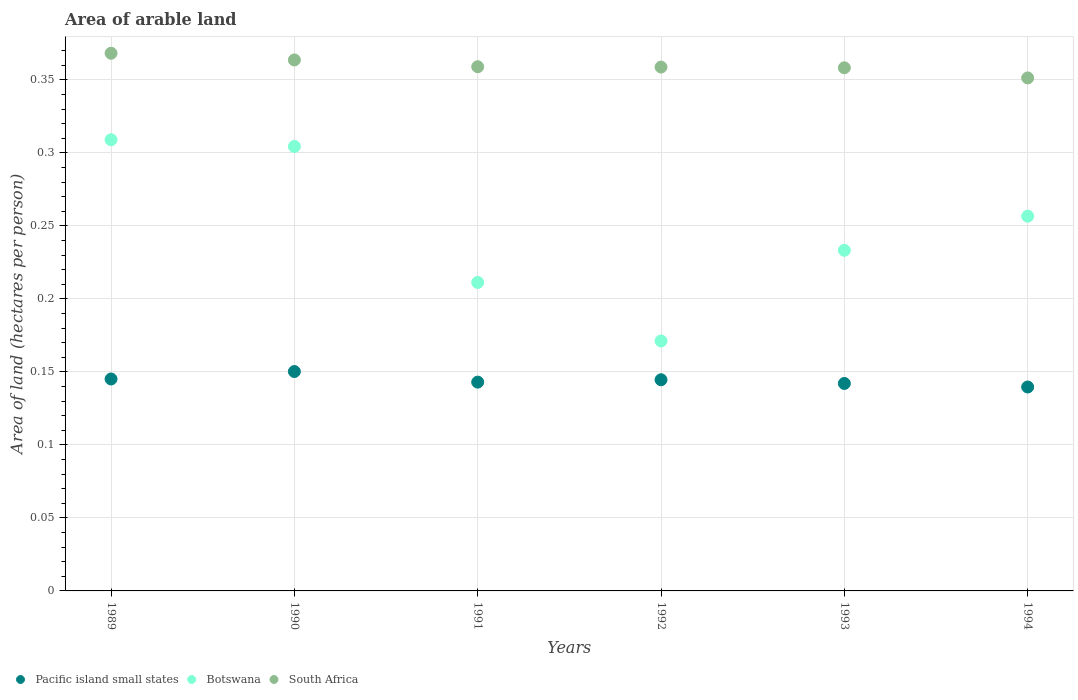What is the total arable land in South Africa in 1991?
Your response must be concise. 0.36. Across all years, what is the maximum total arable land in South Africa?
Keep it short and to the point. 0.37. Across all years, what is the minimum total arable land in Pacific island small states?
Make the answer very short. 0.14. In which year was the total arable land in Pacific island small states minimum?
Give a very brief answer. 1994. What is the total total arable land in Pacific island small states in the graph?
Offer a terse response. 0.86. What is the difference between the total arable land in South Africa in 1989 and that in 1990?
Make the answer very short. 0. What is the difference between the total arable land in Pacific island small states in 1993 and the total arable land in Botswana in 1991?
Ensure brevity in your answer.  -0.07. What is the average total arable land in Pacific island small states per year?
Offer a very short reply. 0.14. In the year 1991, what is the difference between the total arable land in South Africa and total arable land in Pacific island small states?
Your answer should be compact. 0.22. In how many years, is the total arable land in Botswana greater than 0.12000000000000001 hectares per person?
Your answer should be very brief. 6. What is the ratio of the total arable land in South Africa in 1992 to that in 1994?
Provide a short and direct response. 1.02. Is the total arable land in Botswana in 1992 less than that in 1994?
Give a very brief answer. Yes. What is the difference between the highest and the second highest total arable land in South Africa?
Ensure brevity in your answer.  0. What is the difference between the highest and the lowest total arable land in Botswana?
Keep it short and to the point. 0.14. In how many years, is the total arable land in Pacific island small states greater than the average total arable land in Pacific island small states taken over all years?
Ensure brevity in your answer.  3. Is the sum of the total arable land in Pacific island small states in 1991 and 1992 greater than the maximum total arable land in Botswana across all years?
Provide a short and direct response. No. Is it the case that in every year, the sum of the total arable land in South Africa and total arable land in Botswana  is greater than the total arable land in Pacific island small states?
Your response must be concise. Yes. Does the total arable land in South Africa monotonically increase over the years?
Give a very brief answer. No. Is the total arable land in South Africa strictly greater than the total arable land in Botswana over the years?
Offer a terse response. Yes. How many dotlines are there?
Your answer should be compact. 3. What is the difference between two consecutive major ticks on the Y-axis?
Ensure brevity in your answer.  0.05. Are the values on the major ticks of Y-axis written in scientific E-notation?
Offer a terse response. No. Does the graph contain grids?
Provide a short and direct response. Yes. Where does the legend appear in the graph?
Keep it short and to the point. Bottom left. What is the title of the graph?
Give a very brief answer. Area of arable land. Does "New Caledonia" appear as one of the legend labels in the graph?
Your answer should be very brief. No. What is the label or title of the X-axis?
Offer a terse response. Years. What is the label or title of the Y-axis?
Make the answer very short. Area of land (hectares per person). What is the Area of land (hectares per person) of Pacific island small states in 1989?
Offer a terse response. 0.15. What is the Area of land (hectares per person) of Botswana in 1989?
Give a very brief answer. 0.31. What is the Area of land (hectares per person) in South Africa in 1989?
Keep it short and to the point. 0.37. What is the Area of land (hectares per person) in Pacific island small states in 1990?
Provide a short and direct response. 0.15. What is the Area of land (hectares per person) of Botswana in 1990?
Your answer should be very brief. 0.3. What is the Area of land (hectares per person) of South Africa in 1990?
Provide a succinct answer. 0.36. What is the Area of land (hectares per person) in Pacific island small states in 1991?
Offer a very short reply. 0.14. What is the Area of land (hectares per person) in Botswana in 1991?
Keep it short and to the point. 0.21. What is the Area of land (hectares per person) of South Africa in 1991?
Your answer should be very brief. 0.36. What is the Area of land (hectares per person) of Pacific island small states in 1992?
Offer a very short reply. 0.14. What is the Area of land (hectares per person) in Botswana in 1992?
Provide a short and direct response. 0.17. What is the Area of land (hectares per person) of South Africa in 1992?
Make the answer very short. 0.36. What is the Area of land (hectares per person) of Pacific island small states in 1993?
Provide a succinct answer. 0.14. What is the Area of land (hectares per person) of Botswana in 1993?
Provide a short and direct response. 0.23. What is the Area of land (hectares per person) of South Africa in 1993?
Offer a very short reply. 0.36. What is the Area of land (hectares per person) of Pacific island small states in 1994?
Give a very brief answer. 0.14. What is the Area of land (hectares per person) of Botswana in 1994?
Your response must be concise. 0.26. What is the Area of land (hectares per person) in South Africa in 1994?
Keep it short and to the point. 0.35. Across all years, what is the maximum Area of land (hectares per person) in Pacific island small states?
Ensure brevity in your answer.  0.15. Across all years, what is the maximum Area of land (hectares per person) of Botswana?
Your response must be concise. 0.31. Across all years, what is the maximum Area of land (hectares per person) in South Africa?
Offer a terse response. 0.37. Across all years, what is the minimum Area of land (hectares per person) of Pacific island small states?
Ensure brevity in your answer.  0.14. Across all years, what is the minimum Area of land (hectares per person) of Botswana?
Your answer should be very brief. 0.17. Across all years, what is the minimum Area of land (hectares per person) in South Africa?
Make the answer very short. 0.35. What is the total Area of land (hectares per person) of Pacific island small states in the graph?
Provide a succinct answer. 0.86. What is the total Area of land (hectares per person) in Botswana in the graph?
Offer a very short reply. 1.49. What is the total Area of land (hectares per person) of South Africa in the graph?
Keep it short and to the point. 2.16. What is the difference between the Area of land (hectares per person) of Pacific island small states in 1989 and that in 1990?
Make the answer very short. -0.01. What is the difference between the Area of land (hectares per person) of Botswana in 1989 and that in 1990?
Offer a very short reply. 0. What is the difference between the Area of land (hectares per person) in South Africa in 1989 and that in 1990?
Provide a succinct answer. 0. What is the difference between the Area of land (hectares per person) of Pacific island small states in 1989 and that in 1991?
Offer a terse response. 0. What is the difference between the Area of land (hectares per person) of Botswana in 1989 and that in 1991?
Provide a succinct answer. 0.1. What is the difference between the Area of land (hectares per person) in South Africa in 1989 and that in 1991?
Provide a succinct answer. 0.01. What is the difference between the Area of land (hectares per person) of Pacific island small states in 1989 and that in 1992?
Your response must be concise. 0. What is the difference between the Area of land (hectares per person) in Botswana in 1989 and that in 1992?
Offer a terse response. 0.14. What is the difference between the Area of land (hectares per person) in South Africa in 1989 and that in 1992?
Ensure brevity in your answer.  0.01. What is the difference between the Area of land (hectares per person) of Pacific island small states in 1989 and that in 1993?
Offer a very short reply. 0. What is the difference between the Area of land (hectares per person) in Botswana in 1989 and that in 1993?
Give a very brief answer. 0.08. What is the difference between the Area of land (hectares per person) in South Africa in 1989 and that in 1993?
Keep it short and to the point. 0.01. What is the difference between the Area of land (hectares per person) of Pacific island small states in 1989 and that in 1994?
Provide a short and direct response. 0.01. What is the difference between the Area of land (hectares per person) in Botswana in 1989 and that in 1994?
Offer a terse response. 0.05. What is the difference between the Area of land (hectares per person) of South Africa in 1989 and that in 1994?
Offer a very short reply. 0.02. What is the difference between the Area of land (hectares per person) of Pacific island small states in 1990 and that in 1991?
Your answer should be compact. 0.01. What is the difference between the Area of land (hectares per person) in Botswana in 1990 and that in 1991?
Keep it short and to the point. 0.09. What is the difference between the Area of land (hectares per person) in South Africa in 1990 and that in 1991?
Your answer should be very brief. 0. What is the difference between the Area of land (hectares per person) of Pacific island small states in 1990 and that in 1992?
Your answer should be very brief. 0.01. What is the difference between the Area of land (hectares per person) of Botswana in 1990 and that in 1992?
Offer a terse response. 0.13. What is the difference between the Area of land (hectares per person) in South Africa in 1990 and that in 1992?
Give a very brief answer. 0. What is the difference between the Area of land (hectares per person) of Pacific island small states in 1990 and that in 1993?
Your answer should be very brief. 0.01. What is the difference between the Area of land (hectares per person) of Botswana in 1990 and that in 1993?
Your answer should be very brief. 0.07. What is the difference between the Area of land (hectares per person) in South Africa in 1990 and that in 1993?
Give a very brief answer. 0.01. What is the difference between the Area of land (hectares per person) in Pacific island small states in 1990 and that in 1994?
Provide a short and direct response. 0.01. What is the difference between the Area of land (hectares per person) in Botswana in 1990 and that in 1994?
Give a very brief answer. 0.05. What is the difference between the Area of land (hectares per person) in South Africa in 1990 and that in 1994?
Ensure brevity in your answer.  0.01. What is the difference between the Area of land (hectares per person) in Pacific island small states in 1991 and that in 1992?
Keep it short and to the point. -0. What is the difference between the Area of land (hectares per person) in Botswana in 1991 and that in 1992?
Make the answer very short. 0.04. What is the difference between the Area of land (hectares per person) of South Africa in 1991 and that in 1992?
Your answer should be very brief. 0. What is the difference between the Area of land (hectares per person) in Pacific island small states in 1991 and that in 1993?
Provide a short and direct response. 0. What is the difference between the Area of land (hectares per person) of Botswana in 1991 and that in 1993?
Provide a short and direct response. -0.02. What is the difference between the Area of land (hectares per person) of South Africa in 1991 and that in 1993?
Your response must be concise. 0. What is the difference between the Area of land (hectares per person) of Pacific island small states in 1991 and that in 1994?
Give a very brief answer. 0. What is the difference between the Area of land (hectares per person) of Botswana in 1991 and that in 1994?
Give a very brief answer. -0.05. What is the difference between the Area of land (hectares per person) of South Africa in 1991 and that in 1994?
Give a very brief answer. 0.01. What is the difference between the Area of land (hectares per person) in Pacific island small states in 1992 and that in 1993?
Your response must be concise. 0. What is the difference between the Area of land (hectares per person) of Botswana in 1992 and that in 1993?
Offer a very short reply. -0.06. What is the difference between the Area of land (hectares per person) in Pacific island small states in 1992 and that in 1994?
Provide a succinct answer. 0.01. What is the difference between the Area of land (hectares per person) in Botswana in 1992 and that in 1994?
Offer a very short reply. -0.09. What is the difference between the Area of land (hectares per person) of South Africa in 1992 and that in 1994?
Offer a terse response. 0.01. What is the difference between the Area of land (hectares per person) of Pacific island small states in 1993 and that in 1994?
Provide a short and direct response. 0. What is the difference between the Area of land (hectares per person) of Botswana in 1993 and that in 1994?
Your answer should be compact. -0.02. What is the difference between the Area of land (hectares per person) of South Africa in 1993 and that in 1994?
Make the answer very short. 0.01. What is the difference between the Area of land (hectares per person) of Pacific island small states in 1989 and the Area of land (hectares per person) of Botswana in 1990?
Give a very brief answer. -0.16. What is the difference between the Area of land (hectares per person) in Pacific island small states in 1989 and the Area of land (hectares per person) in South Africa in 1990?
Your answer should be very brief. -0.22. What is the difference between the Area of land (hectares per person) of Botswana in 1989 and the Area of land (hectares per person) of South Africa in 1990?
Offer a terse response. -0.05. What is the difference between the Area of land (hectares per person) in Pacific island small states in 1989 and the Area of land (hectares per person) in Botswana in 1991?
Give a very brief answer. -0.07. What is the difference between the Area of land (hectares per person) in Pacific island small states in 1989 and the Area of land (hectares per person) in South Africa in 1991?
Your answer should be very brief. -0.21. What is the difference between the Area of land (hectares per person) in Botswana in 1989 and the Area of land (hectares per person) in South Africa in 1991?
Offer a terse response. -0.05. What is the difference between the Area of land (hectares per person) in Pacific island small states in 1989 and the Area of land (hectares per person) in Botswana in 1992?
Ensure brevity in your answer.  -0.03. What is the difference between the Area of land (hectares per person) of Pacific island small states in 1989 and the Area of land (hectares per person) of South Africa in 1992?
Your response must be concise. -0.21. What is the difference between the Area of land (hectares per person) of Botswana in 1989 and the Area of land (hectares per person) of South Africa in 1992?
Make the answer very short. -0.05. What is the difference between the Area of land (hectares per person) in Pacific island small states in 1989 and the Area of land (hectares per person) in Botswana in 1993?
Make the answer very short. -0.09. What is the difference between the Area of land (hectares per person) in Pacific island small states in 1989 and the Area of land (hectares per person) in South Africa in 1993?
Provide a short and direct response. -0.21. What is the difference between the Area of land (hectares per person) in Botswana in 1989 and the Area of land (hectares per person) in South Africa in 1993?
Ensure brevity in your answer.  -0.05. What is the difference between the Area of land (hectares per person) of Pacific island small states in 1989 and the Area of land (hectares per person) of Botswana in 1994?
Make the answer very short. -0.11. What is the difference between the Area of land (hectares per person) of Pacific island small states in 1989 and the Area of land (hectares per person) of South Africa in 1994?
Make the answer very short. -0.21. What is the difference between the Area of land (hectares per person) of Botswana in 1989 and the Area of land (hectares per person) of South Africa in 1994?
Ensure brevity in your answer.  -0.04. What is the difference between the Area of land (hectares per person) in Pacific island small states in 1990 and the Area of land (hectares per person) in Botswana in 1991?
Offer a terse response. -0.06. What is the difference between the Area of land (hectares per person) in Pacific island small states in 1990 and the Area of land (hectares per person) in South Africa in 1991?
Ensure brevity in your answer.  -0.21. What is the difference between the Area of land (hectares per person) in Botswana in 1990 and the Area of land (hectares per person) in South Africa in 1991?
Make the answer very short. -0.05. What is the difference between the Area of land (hectares per person) in Pacific island small states in 1990 and the Area of land (hectares per person) in Botswana in 1992?
Give a very brief answer. -0.02. What is the difference between the Area of land (hectares per person) of Pacific island small states in 1990 and the Area of land (hectares per person) of South Africa in 1992?
Your answer should be very brief. -0.21. What is the difference between the Area of land (hectares per person) of Botswana in 1990 and the Area of land (hectares per person) of South Africa in 1992?
Make the answer very short. -0.05. What is the difference between the Area of land (hectares per person) of Pacific island small states in 1990 and the Area of land (hectares per person) of Botswana in 1993?
Keep it short and to the point. -0.08. What is the difference between the Area of land (hectares per person) of Pacific island small states in 1990 and the Area of land (hectares per person) of South Africa in 1993?
Provide a short and direct response. -0.21. What is the difference between the Area of land (hectares per person) of Botswana in 1990 and the Area of land (hectares per person) of South Africa in 1993?
Your answer should be compact. -0.05. What is the difference between the Area of land (hectares per person) of Pacific island small states in 1990 and the Area of land (hectares per person) of Botswana in 1994?
Provide a succinct answer. -0.11. What is the difference between the Area of land (hectares per person) of Pacific island small states in 1990 and the Area of land (hectares per person) of South Africa in 1994?
Your answer should be compact. -0.2. What is the difference between the Area of land (hectares per person) of Botswana in 1990 and the Area of land (hectares per person) of South Africa in 1994?
Your response must be concise. -0.05. What is the difference between the Area of land (hectares per person) in Pacific island small states in 1991 and the Area of land (hectares per person) in Botswana in 1992?
Provide a short and direct response. -0.03. What is the difference between the Area of land (hectares per person) of Pacific island small states in 1991 and the Area of land (hectares per person) of South Africa in 1992?
Keep it short and to the point. -0.22. What is the difference between the Area of land (hectares per person) of Botswana in 1991 and the Area of land (hectares per person) of South Africa in 1992?
Offer a very short reply. -0.15. What is the difference between the Area of land (hectares per person) in Pacific island small states in 1991 and the Area of land (hectares per person) in Botswana in 1993?
Offer a terse response. -0.09. What is the difference between the Area of land (hectares per person) of Pacific island small states in 1991 and the Area of land (hectares per person) of South Africa in 1993?
Keep it short and to the point. -0.22. What is the difference between the Area of land (hectares per person) of Botswana in 1991 and the Area of land (hectares per person) of South Africa in 1993?
Give a very brief answer. -0.15. What is the difference between the Area of land (hectares per person) in Pacific island small states in 1991 and the Area of land (hectares per person) in Botswana in 1994?
Keep it short and to the point. -0.11. What is the difference between the Area of land (hectares per person) of Pacific island small states in 1991 and the Area of land (hectares per person) of South Africa in 1994?
Keep it short and to the point. -0.21. What is the difference between the Area of land (hectares per person) of Botswana in 1991 and the Area of land (hectares per person) of South Africa in 1994?
Your answer should be very brief. -0.14. What is the difference between the Area of land (hectares per person) in Pacific island small states in 1992 and the Area of land (hectares per person) in Botswana in 1993?
Your answer should be compact. -0.09. What is the difference between the Area of land (hectares per person) of Pacific island small states in 1992 and the Area of land (hectares per person) of South Africa in 1993?
Make the answer very short. -0.21. What is the difference between the Area of land (hectares per person) of Botswana in 1992 and the Area of land (hectares per person) of South Africa in 1993?
Keep it short and to the point. -0.19. What is the difference between the Area of land (hectares per person) in Pacific island small states in 1992 and the Area of land (hectares per person) in Botswana in 1994?
Provide a short and direct response. -0.11. What is the difference between the Area of land (hectares per person) in Pacific island small states in 1992 and the Area of land (hectares per person) in South Africa in 1994?
Keep it short and to the point. -0.21. What is the difference between the Area of land (hectares per person) in Botswana in 1992 and the Area of land (hectares per person) in South Africa in 1994?
Your response must be concise. -0.18. What is the difference between the Area of land (hectares per person) of Pacific island small states in 1993 and the Area of land (hectares per person) of Botswana in 1994?
Offer a terse response. -0.11. What is the difference between the Area of land (hectares per person) of Pacific island small states in 1993 and the Area of land (hectares per person) of South Africa in 1994?
Offer a terse response. -0.21. What is the difference between the Area of land (hectares per person) of Botswana in 1993 and the Area of land (hectares per person) of South Africa in 1994?
Ensure brevity in your answer.  -0.12. What is the average Area of land (hectares per person) of Pacific island small states per year?
Your answer should be very brief. 0.14. What is the average Area of land (hectares per person) of Botswana per year?
Your response must be concise. 0.25. What is the average Area of land (hectares per person) of South Africa per year?
Make the answer very short. 0.36. In the year 1989, what is the difference between the Area of land (hectares per person) of Pacific island small states and Area of land (hectares per person) of Botswana?
Your answer should be very brief. -0.16. In the year 1989, what is the difference between the Area of land (hectares per person) in Pacific island small states and Area of land (hectares per person) in South Africa?
Provide a succinct answer. -0.22. In the year 1989, what is the difference between the Area of land (hectares per person) in Botswana and Area of land (hectares per person) in South Africa?
Give a very brief answer. -0.06. In the year 1990, what is the difference between the Area of land (hectares per person) in Pacific island small states and Area of land (hectares per person) in Botswana?
Your answer should be very brief. -0.15. In the year 1990, what is the difference between the Area of land (hectares per person) in Pacific island small states and Area of land (hectares per person) in South Africa?
Offer a terse response. -0.21. In the year 1990, what is the difference between the Area of land (hectares per person) of Botswana and Area of land (hectares per person) of South Africa?
Make the answer very short. -0.06. In the year 1991, what is the difference between the Area of land (hectares per person) of Pacific island small states and Area of land (hectares per person) of Botswana?
Your answer should be very brief. -0.07. In the year 1991, what is the difference between the Area of land (hectares per person) of Pacific island small states and Area of land (hectares per person) of South Africa?
Your answer should be compact. -0.22. In the year 1991, what is the difference between the Area of land (hectares per person) of Botswana and Area of land (hectares per person) of South Africa?
Your response must be concise. -0.15. In the year 1992, what is the difference between the Area of land (hectares per person) of Pacific island small states and Area of land (hectares per person) of Botswana?
Offer a terse response. -0.03. In the year 1992, what is the difference between the Area of land (hectares per person) in Pacific island small states and Area of land (hectares per person) in South Africa?
Your answer should be very brief. -0.21. In the year 1992, what is the difference between the Area of land (hectares per person) in Botswana and Area of land (hectares per person) in South Africa?
Make the answer very short. -0.19. In the year 1993, what is the difference between the Area of land (hectares per person) of Pacific island small states and Area of land (hectares per person) of Botswana?
Make the answer very short. -0.09. In the year 1993, what is the difference between the Area of land (hectares per person) of Pacific island small states and Area of land (hectares per person) of South Africa?
Your response must be concise. -0.22. In the year 1993, what is the difference between the Area of land (hectares per person) in Botswana and Area of land (hectares per person) in South Africa?
Your answer should be very brief. -0.12. In the year 1994, what is the difference between the Area of land (hectares per person) in Pacific island small states and Area of land (hectares per person) in Botswana?
Your answer should be compact. -0.12. In the year 1994, what is the difference between the Area of land (hectares per person) in Pacific island small states and Area of land (hectares per person) in South Africa?
Offer a very short reply. -0.21. In the year 1994, what is the difference between the Area of land (hectares per person) in Botswana and Area of land (hectares per person) in South Africa?
Offer a very short reply. -0.09. What is the ratio of the Area of land (hectares per person) of Pacific island small states in 1989 to that in 1990?
Provide a succinct answer. 0.97. What is the ratio of the Area of land (hectares per person) in Botswana in 1989 to that in 1990?
Provide a short and direct response. 1.02. What is the ratio of the Area of land (hectares per person) of South Africa in 1989 to that in 1990?
Make the answer very short. 1.01. What is the ratio of the Area of land (hectares per person) in Botswana in 1989 to that in 1991?
Keep it short and to the point. 1.46. What is the ratio of the Area of land (hectares per person) in South Africa in 1989 to that in 1991?
Your answer should be compact. 1.03. What is the ratio of the Area of land (hectares per person) in Pacific island small states in 1989 to that in 1992?
Your answer should be very brief. 1. What is the ratio of the Area of land (hectares per person) in Botswana in 1989 to that in 1992?
Your answer should be very brief. 1.81. What is the ratio of the Area of land (hectares per person) of South Africa in 1989 to that in 1992?
Give a very brief answer. 1.03. What is the ratio of the Area of land (hectares per person) of Pacific island small states in 1989 to that in 1993?
Keep it short and to the point. 1.02. What is the ratio of the Area of land (hectares per person) of Botswana in 1989 to that in 1993?
Offer a very short reply. 1.32. What is the ratio of the Area of land (hectares per person) in South Africa in 1989 to that in 1993?
Your response must be concise. 1.03. What is the ratio of the Area of land (hectares per person) in Pacific island small states in 1989 to that in 1994?
Provide a succinct answer. 1.04. What is the ratio of the Area of land (hectares per person) of Botswana in 1989 to that in 1994?
Your response must be concise. 1.2. What is the ratio of the Area of land (hectares per person) of South Africa in 1989 to that in 1994?
Give a very brief answer. 1.05. What is the ratio of the Area of land (hectares per person) in Pacific island small states in 1990 to that in 1991?
Give a very brief answer. 1.05. What is the ratio of the Area of land (hectares per person) in Botswana in 1990 to that in 1991?
Your answer should be very brief. 1.44. What is the ratio of the Area of land (hectares per person) in South Africa in 1990 to that in 1991?
Your answer should be very brief. 1.01. What is the ratio of the Area of land (hectares per person) in Pacific island small states in 1990 to that in 1992?
Provide a short and direct response. 1.04. What is the ratio of the Area of land (hectares per person) of Botswana in 1990 to that in 1992?
Keep it short and to the point. 1.78. What is the ratio of the Area of land (hectares per person) in South Africa in 1990 to that in 1992?
Provide a succinct answer. 1.01. What is the ratio of the Area of land (hectares per person) in Pacific island small states in 1990 to that in 1993?
Ensure brevity in your answer.  1.06. What is the ratio of the Area of land (hectares per person) of Botswana in 1990 to that in 1993?
Keep it short and to the point. 1.3. What is the ratio of the Area of land (hectares per person) in Pacific island small states in 1990 to that in 1994?
Offer a very short reply. 1.08. What is the ratio of the Area of land (hectares per person) of Botswana in 1990 to that in 1994?
Your response must be concise. 1.19. What is the ratio of the Area of land (hectares per person) in South Africa in 1990 to that in 1994?
Keep it short and to the point. 1.03. What is the ratio of the Area of land (hectares per person) in Pacific island small states in 1991 to that in 1992?
Provide a succinct answer. 0.99. What is the ratio of the Area of land (hectares per person) in Botswana in 1991 to that in 1992?
Your answer should be very brief. 1.23. What is the ratio of the Area of land (hectares per person) in Botswana in 1991 to that in 1993?
Make the answer very short. 0.91. What is the ratio of the Area of land (hectares per person) of Pacific island small states in 1991 to that in 1994?
Offer a very short reply. 1.02. What is the ratio of the Area of land (hectares per person) in Botswana in 1991 to that in 1994?
Give a very brief answer. 0.82. What is the ratio of the Area of land (hectares per person) of South Africa in 1991 to that in 1994?
Keep it short and to the point. 1.02. What is the ratio of the Area of land (hectares per person) in Pacific island small states in 1992 to that in 1993?
Your answer should be compact. 1.02. What is the ratio of the Area of land (hectares per person) of Botswana in 1992 to that in 1993?
Offer a very short reply. 0.73. What is the ratio of the Area of land (hectares per person) in South Africa in 1992 to that in 1993?
Keep it short and to the point. 1. What is the ratio of the Area of land (hectares per person) in Pacific island small states in 1992 to that in 1994?
Make the answer very short. 1.04. What is the ratio of the Area of land (hectares per person) of Botswana in 1992 to that in 1994?
Provide a succinct answer. 0.67. What is the ratio of the Area of land (hectares per person) in South Africa in 1992 to that in 1994?
Your answer should be compact. 1.02. What is the ratio of the Area of land (hectares per person) of Pacific island small states in 1993 to that in 1994?
Your answer should be very brief. 1.02. What is the ratio of the Area of land (hectares per person) of Botswana in 1993 to that in 1994?
Your answer should be compact. 0.91. What is the ratio of the Area of land (hectares per person) of South Africa in 1993 to that in 1994?
Offer a terse response. 1.02. What is the difference between the highest and the second highest Area of land (hectares per person) of Pacific island small states?
Your response must be concise. 0.01. What is the difference between the highest and the second highest Area of land (hectares per person) in Botswana?
Your answer should be very brief. 0. What is the difference between the highest and the second highest Area of land (hectares per person) in South Africa?
Make the answer very short. 0. What is the difference between the highest and the lowest Area of land (hectares per person) in Pacific island small states?
Your answer should be compact. 0.01. What is the difference between the highest and the lowest Area of land (hectares per person) in Botswana?
Your answer should be compact. 0.14. What is the difference between the highest and the lowest Area of land (hectares per person) in South Africa?
Offer a terse response. 0.02. 